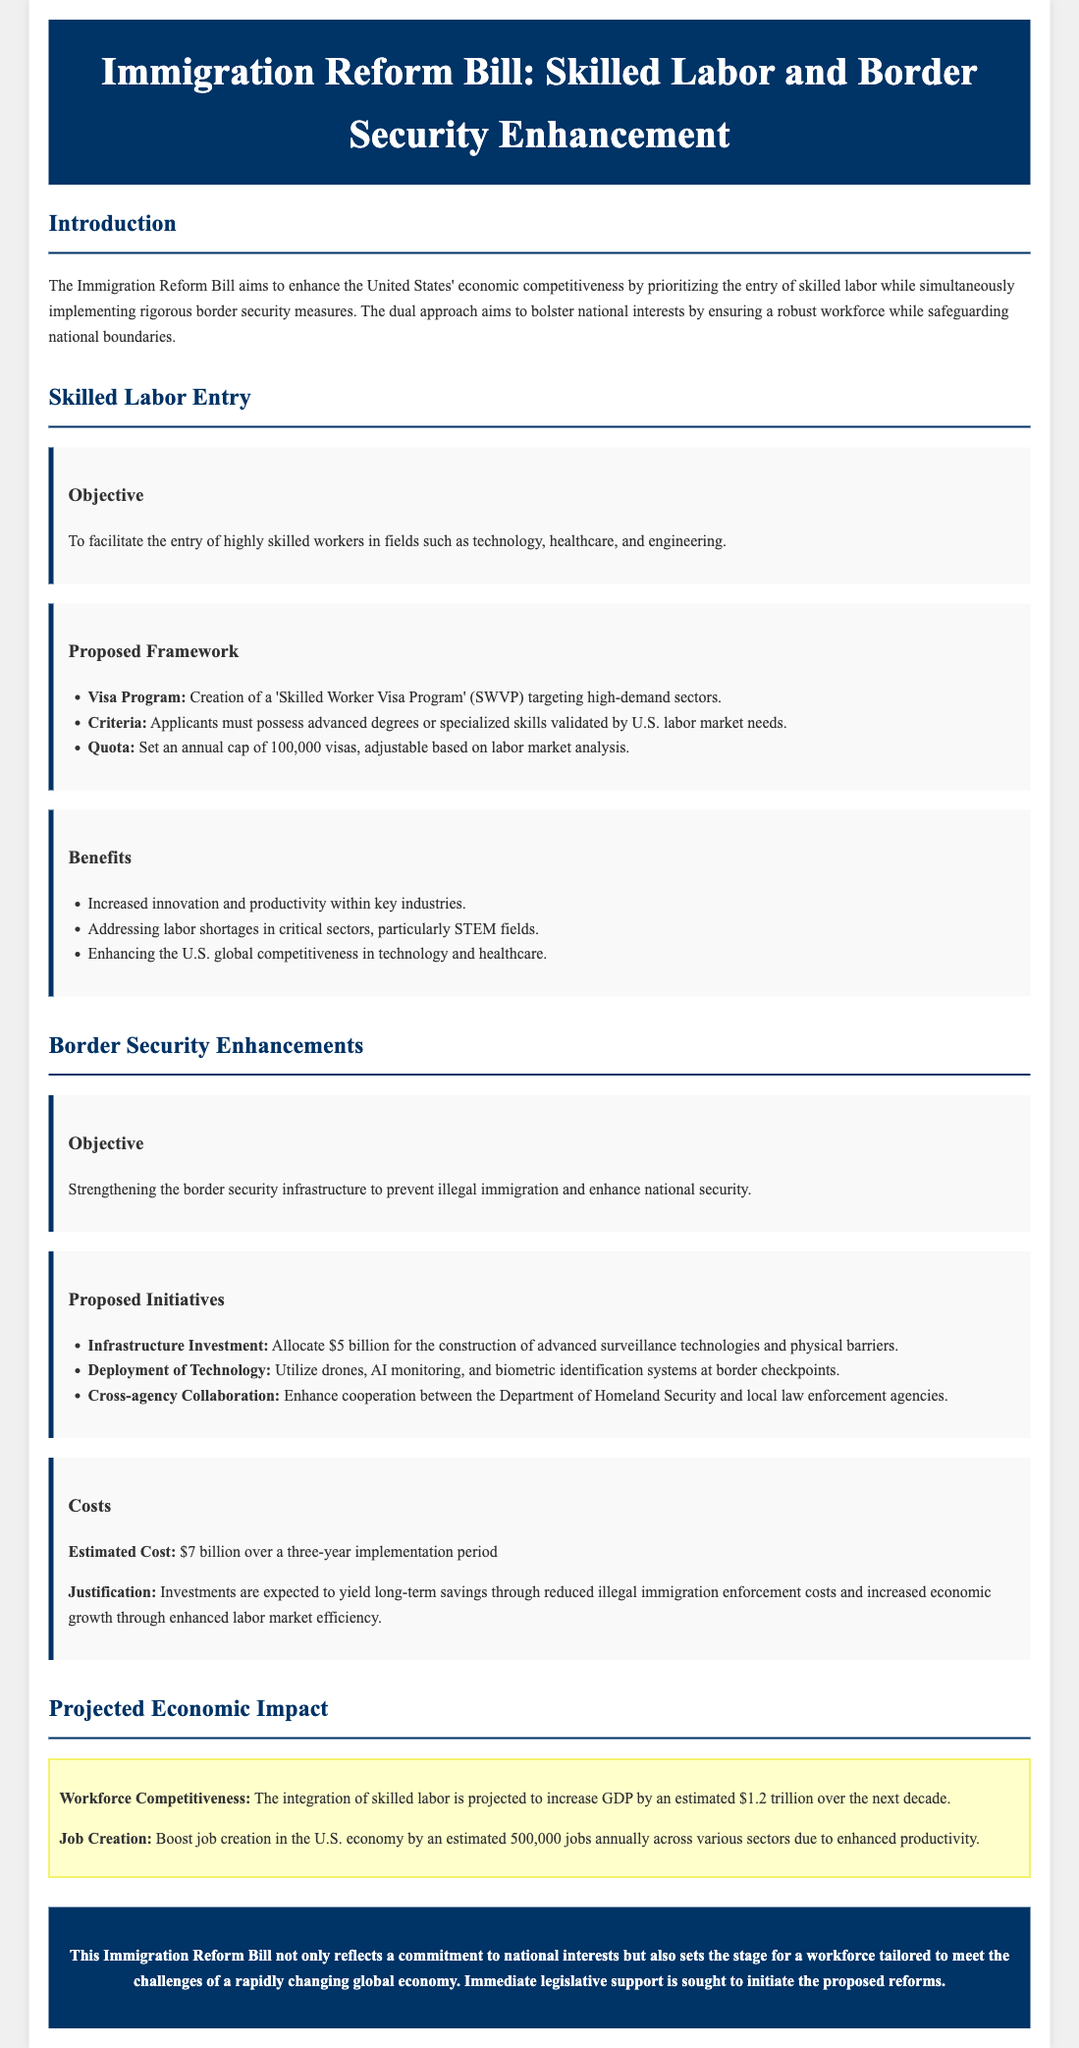What is the title of the bill? The title is found in the header section of the document.
Answer: Immigration Reform Bill: Skilled Labor and Border Security Enhancement How much funding is allocated for border security enhancements? The funding amount is specified in the border security section.
Answer: $5 billion What is the annual cap for the Skilled Worker Visa Program? The annual cap is mentioned in the proposed framework for skilled labor entry.
Answer: 100,000 visas What is the estimated cost of the proposed immigration reforms? The estimated cost is stated in the costs section of the border security enhancements.
Answer: $7 billion How much is projected to be added to GDP over the next decade? This figure is mentioned in the projected economic impact section.
Answer: $1.2 trillion How many jobs are expected to be created annually due to the reforms? The number of jobs created is highlighted in the projected economic impact section.
Answer: 500,000 jobs What are the primary fields targeted by the Skilled Worker Visa Program? The fields are listed in the objective of skilled labor entry.
Answer: Technology, healthcare, and engineering What type of technology will be utilized at border checkpoints? This information is found in the proposed initiatives section of border security enhancements.
Answer: Drones, AI monitoring, and biometric identification systems What is the objective of the Immigration Reform Bill? The objective is summarized in the introduction section of the document.
Answer: Enhance economic competitiveness and safeguard national boundaries 